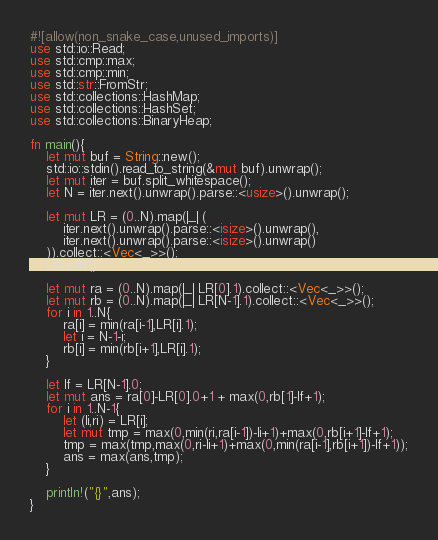<code> <loc_0><loc_0><loc_500><loc_500><_Rust_>#![allow(non_snake_case,unused_imports)]
use std::io::Read;
use std::cmp::max;
use std::cmp::min;
use std::str::FromStr;
use std::collections::HashMap;
use std::collections::HashSet;
use std::collections::BinaryHeap;

fn main(){
    let mut buf = String::new();
    std::io::stdin().read_to_string(&mut buf).unwrap();
    let mut iter = buf.split_whitespace();
    let N = iter.next().unwrap().parse::<usize>().unwrap();
    
    let mut LR = (0..N).map(|_| (
        iter.next().unwrap().parse::<isize>().unwrap(),
        iter.next().unwrap().parse::<isize>().unwrap()
    )).collect::<Vec<_>>();
    LR.sort();

    let mut ra = (0..N).map(|_| LR[0].1).collect::<Vec<_>>();
    let mut rb = (0..N).map(|_| LR[N-1].1).collect::<Vec<_>>();
    for i in 1..N{
        ra[i] = min(ra[i-1],LR[i].1);
        let i = N-1-i;
        rb[i] = min(rb[i+1],LR[i].1);
    }

    let lf = LR[N-1].0;
    let mut ans = ra[0]-LR[0].0+1 + max(0,rb[1]-lf+1);
    for i in 1..N-1{
        let (li,ri) = LR[i];
        let mut tmp = max(0,min(ri,ra[i-1])-li+1)+max(0,rb[i+1]-lf+1);
        tmp = max(tmp,max(0,ri-li+1)+max(0,min(ra[i-1],rb[i+1])-lf+1));
        ans = max(ans,tmp);
    }

    println!("{}",ans);
}
</code> 